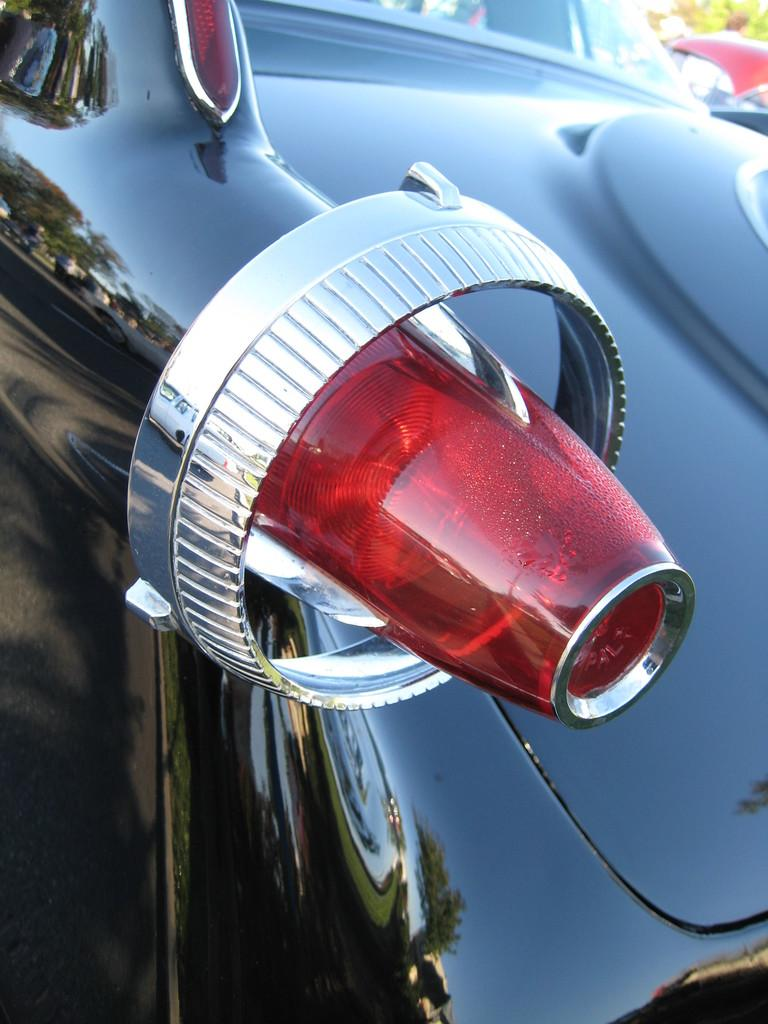What is the main subject of the image? The main subject of the image is a car. What feature can be seen on the front of the car? There is a danger light in the front of the car. What type of natural element is visible in the image? There is a tree at the right top of the image. What type of nut is being used to secure the coat in the image? There is no nut or coat present in the image; it only features a car with a danger light and a tree in the background. 